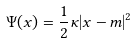<formula> <loc_0><loc_0><loc_500><loc_500>\Psi ( x ) = \frac { 1 } { 2 } \kappa | x - m | ^ { 2 }</formula> 